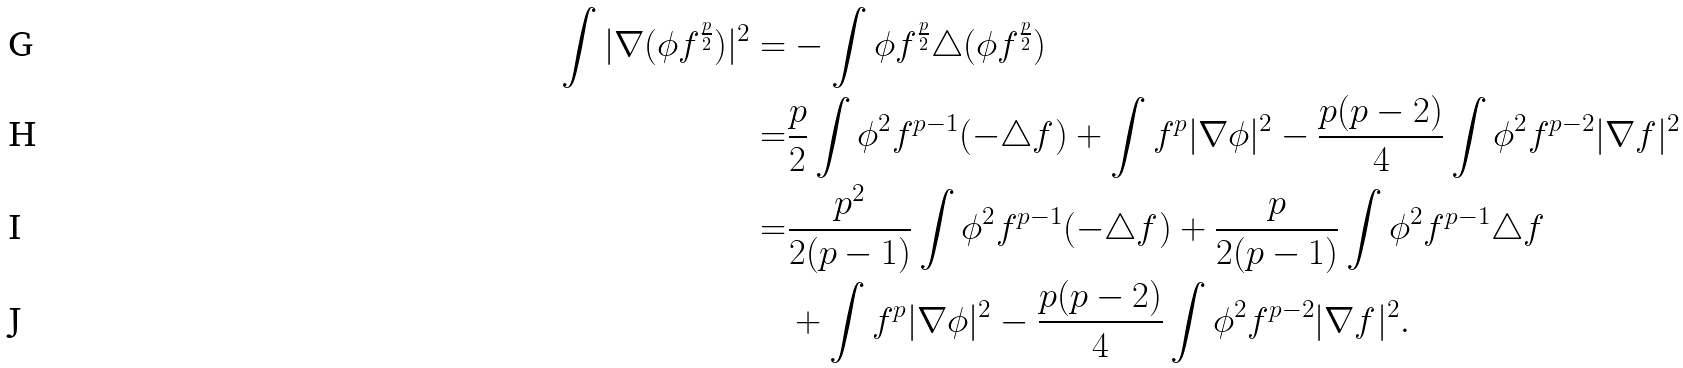<formula> <loc_0><loc_0><loc_500><loc_500>\int | \nabla ( \phi f ^ { \frac { p } { 2 } } ) | ^ { 2 } = & - \int \phi f ^ { \frac { p } { 2 } } \triangle ( \phi f ^ { \frac { p } { 2 } } ) \\ = & \frac { p } { 2 } \int \phi ^ { 2 } f ^ { p - 1 } ( - \triangle f ) + \int f ^ { p } | \nabla \phi | ^ { 2 } - \frac { p ( p - 2 ) } { 4 } \int \phi ^ { 2 } f ^ { p - 2 } | \nabla f | ^ { 2 } \\ = & \frac { p ^ { 2 } } { 2 ( p - 1 ) } \int \phi ^ { 2 } f ^ { p - 1 } ( - \triangle f ) + \frac { p } { 2 ( p - 1 ) } \int \phi ^ { 2 } f ^ { p - 1 } \triangle f \\ & + \int f ^ { p } | \nabla \phi | ^ { 2 } - \frac { p ( p - 2 ) } { 4 } \int \phi ^ { 2 } f ^ { p - 2 } | \nabla f | ^ { 2 } .</formula> 